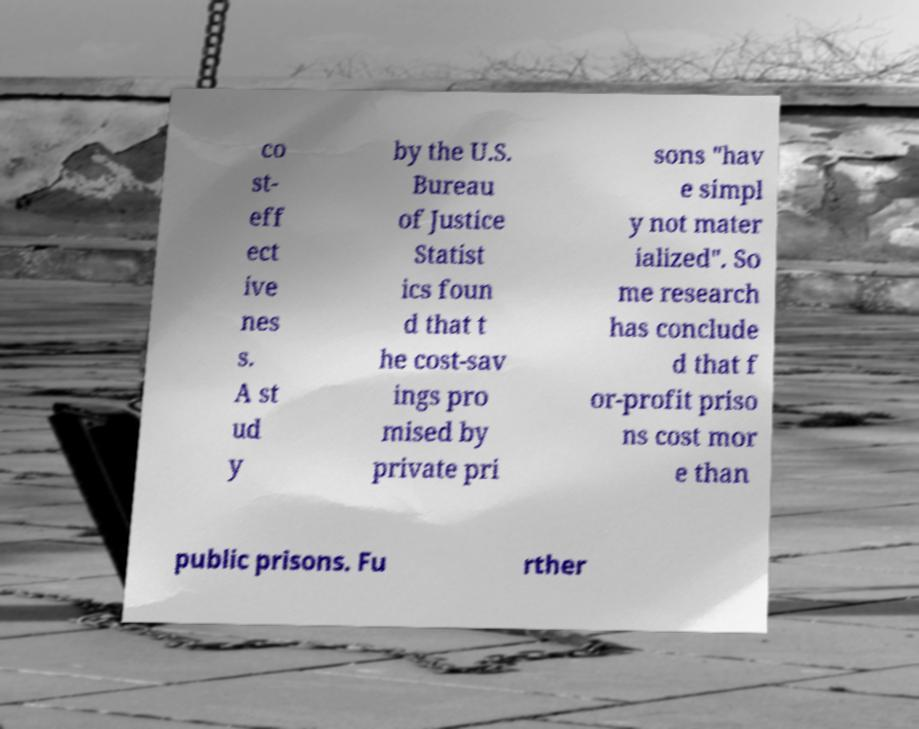Could you assist in decoding the text presented in this image and type it out clearly? co st- eff ect ive nes s. A st ud y by the U.S. Bureau of Justice Statist ics foun d that t he cost-sav ings pro mised by private pri sons "hav e simpl y not mater ialized". So me research has conclude d that f or-profit priso ns cost mor e than public prisons. Fu rther 